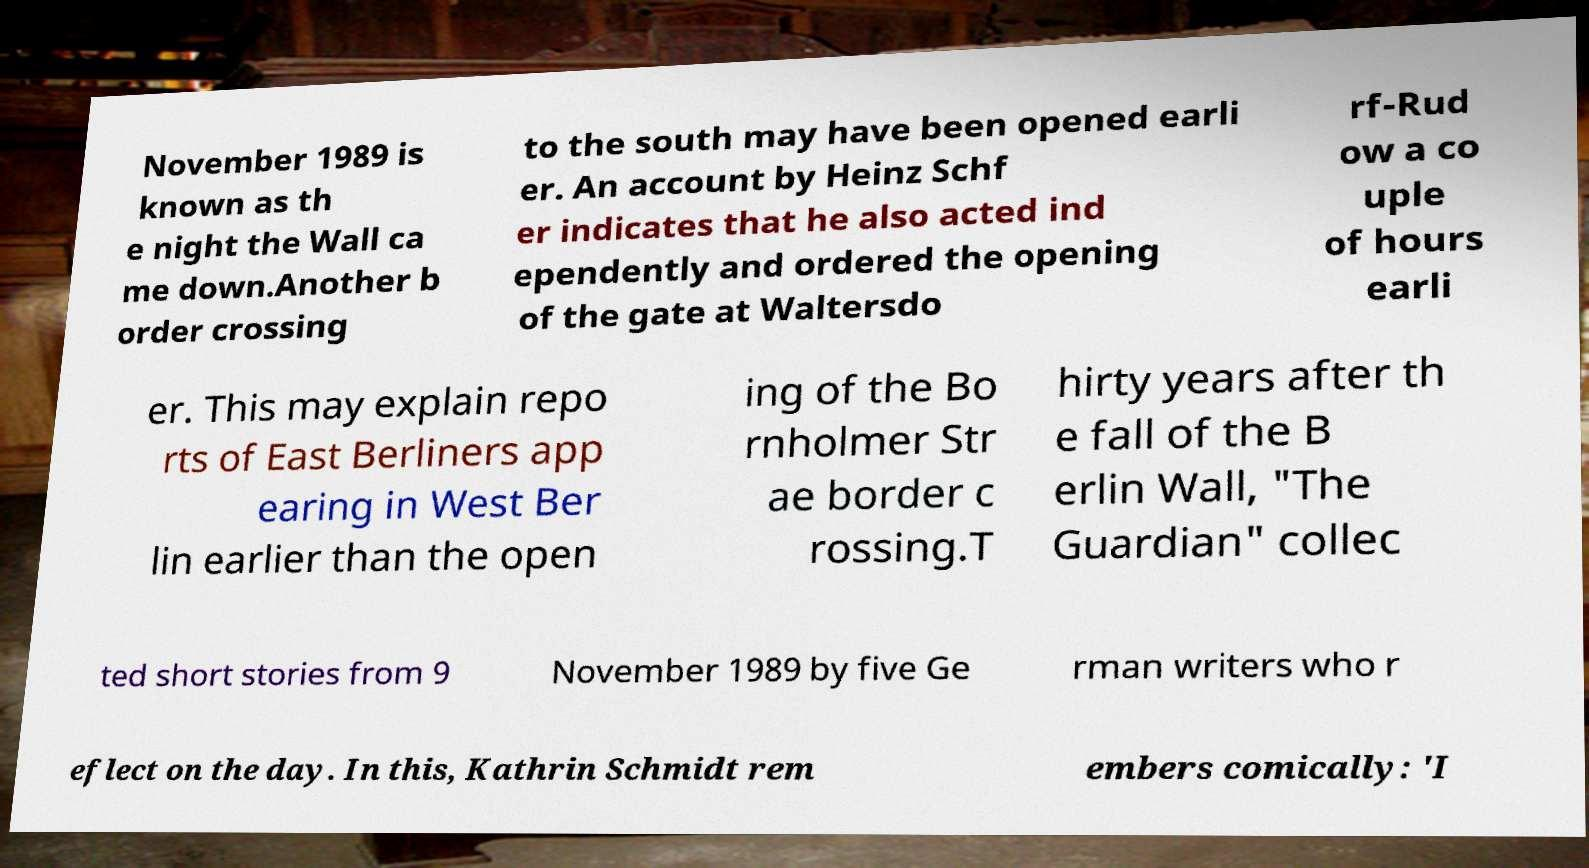Can you accurately transcribe the text from the provided image for me? November 1989 is known as th e night the Wall ca me down.Another b order crossing to the south may have been opened earli er. An account by Heinz Schf er indicates that he also acted ind ependently and ordered the opening of the gate at Waltersdo rf-Rud ow a co uple of hours earli er. This may explain repo rts of East Berliners app earing in West Ber lin earlier than the open ing of the Bo rnholmer Str ae border c rossing.T hirty years after th e fall of the B erlin Wall, "The Guardian" collec ted short stories from 9 November 1989 by five Ge rman writers who r eflect on the day. In this, Kathrin Schmidt rem embers comically: 'I 